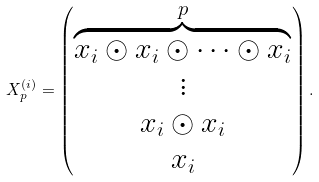Convert formula to latex. <formula><loc_0><loc_0><loc_500><loc_500>X _ { p } ^ { ( i ) } = \begin{pmatrix} \overbrace { x _ { i } \odot x _ { i } \odot \cdots \odot x _ { i } } ^ { p } \\ \vdots \\ x _ { i } \odot x _ { i } \\ x _ { i } \\ \end{pmatrix} .</formula> 